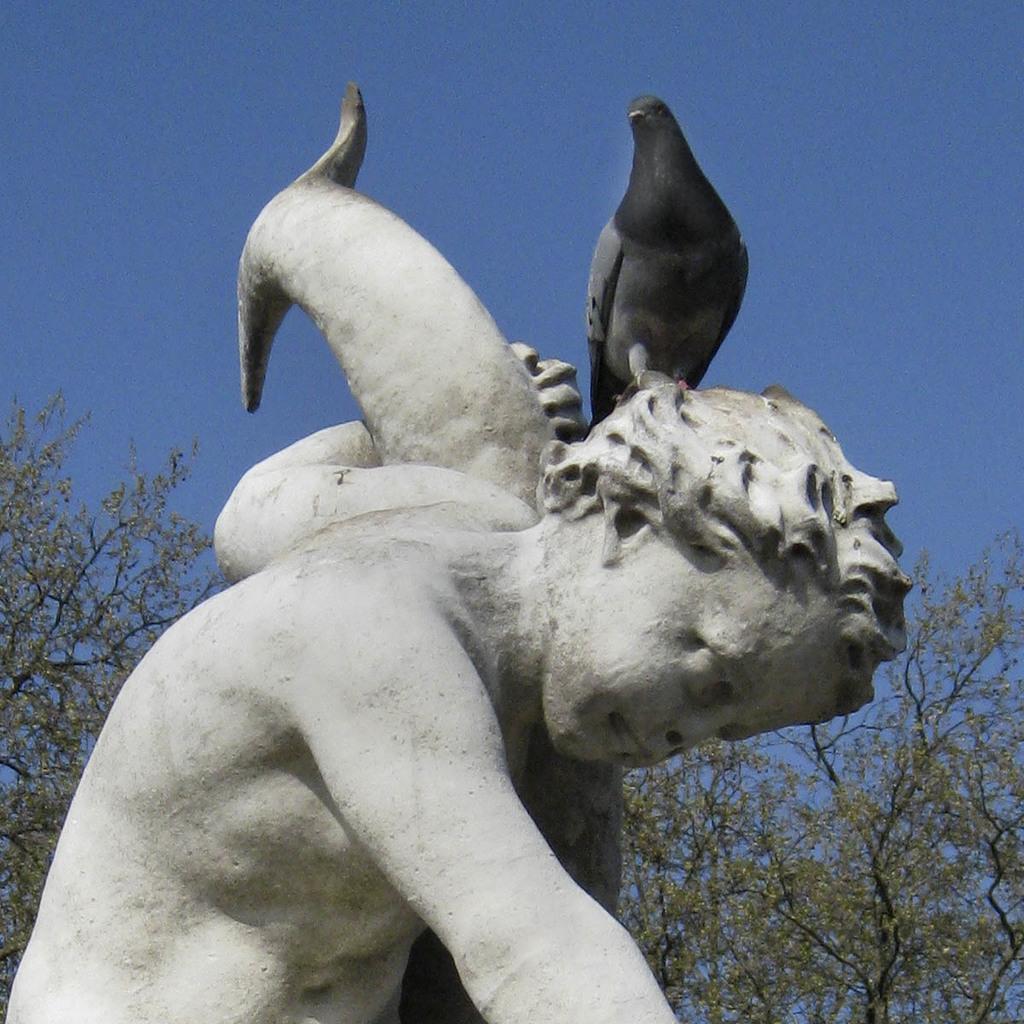Can you describe this image briefly? In this image there is the sky towards the top of the image, there is a sculptor towards the bottom of the image, there are trees towards the bottom of the image, there is a bird on the sculptor. 